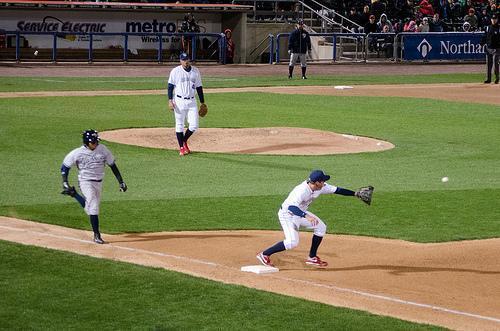How many players are shown?
Give a very brief answer. 3. 